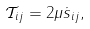Convert formula to latex. <formula><loc_0><loc_0><loc_500><loc_500>\mathcal { T } _ { i j } = 2 \mu \dot { s } _ { i j } ,</formula> 